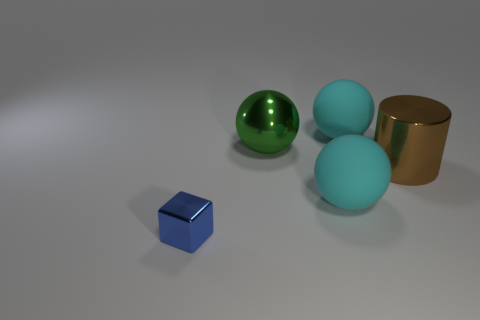How many objects are brown things or big purple shiny things?
Keep it short and to the point. 1. What is the color of the big ball in front of the shiny cylinder?
Your response must be concise. Cyan. How many things are things that are to the right of the small blue metal object or large metal things that are behind the large shiny cylinder?
Your response must be concise. 4. What is the size of the metallic thing that is left of the big metal cylinder and in front of the large metallic ball?
Ensure brevity in your answer.  Small. Does the big brown object have the same shape as the cyan object that is in front of the brown metal cylinder?
Provide a succinct answer. No. What number of objects are either rubber objects that are in front of the large green shiny thing or blue objects?
Provide a short and direct response. 2. Are the brown cylinder and the cyan object behind the large shiny sphere made of the same material?
Provide a short and direct response. No. What shape is the cyan matte thing in front of the large cyan matte thing behind the green ball?
Your answer should be compact. Sphere. What is the shape of the large green object?
Keep it short and to the point. Sphere. How big is the cyan matte sphere on the left side of the large object behind the green object?
Offer a very short reply. Large. 